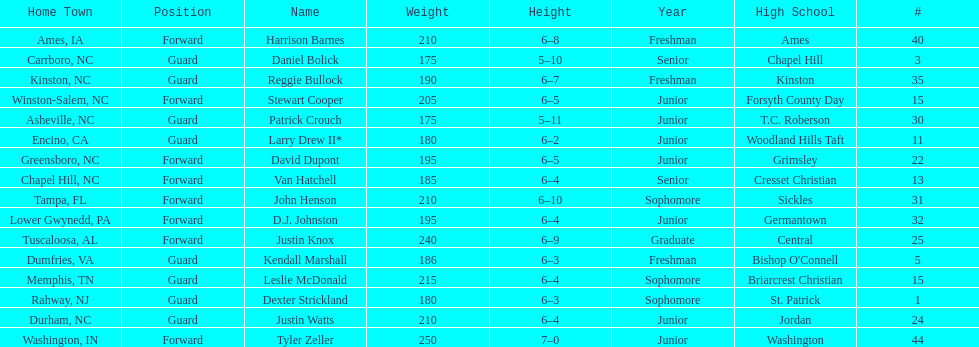Total number of players whose home town was in north carolina (nc) 7. 